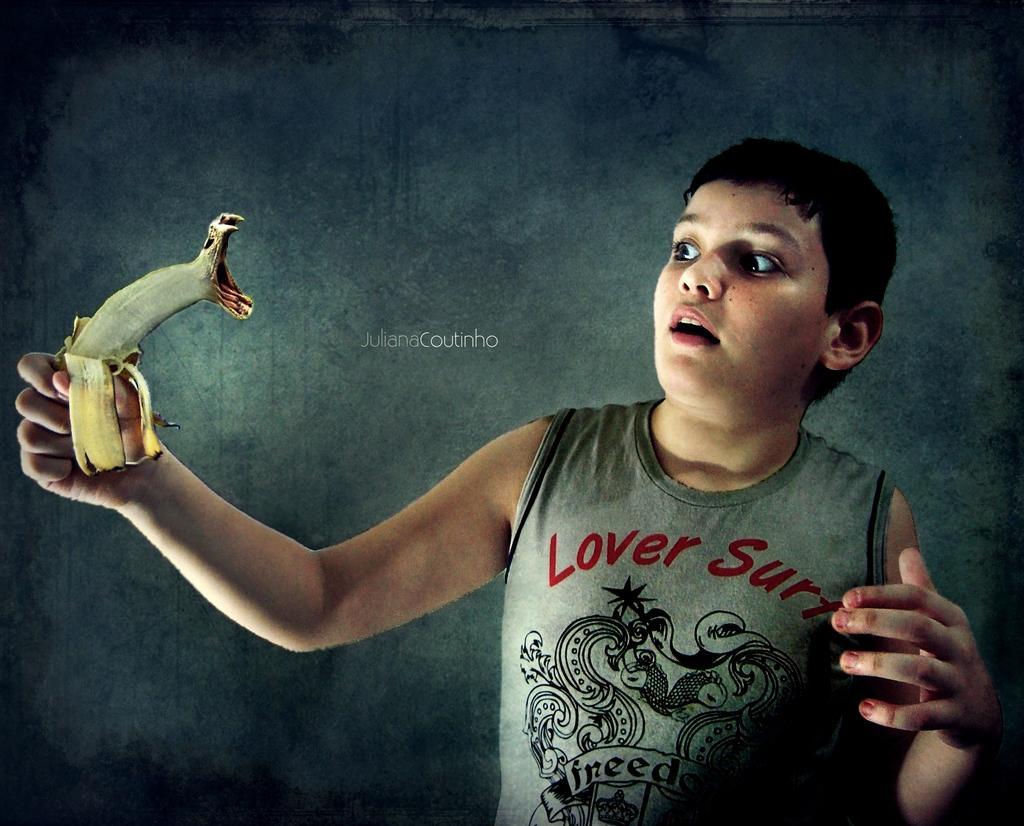How would you summarize this image in a sentence or two? In this image I can see a boy and I can see he is wearing grey colour dress. On his dress I can see something is written. Here I can see he is holding an object. I can also see watermark over here. 